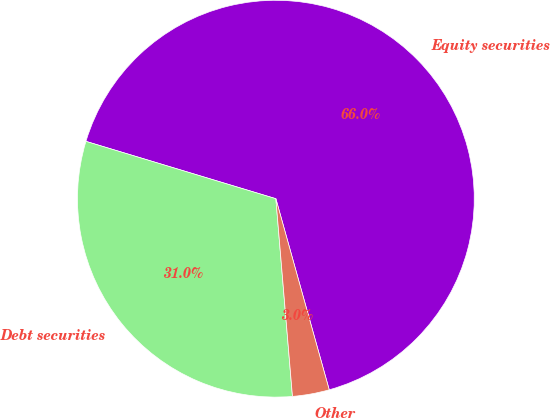<chart> <loc_0><loc_0><loc_500><loc_500><pie_chart><fcel>Equity securities<fcel>Debt securities<fcel>Other<nl><fcel>66.0%<fcel>31.0%<fcel>3.0%<nl></chart> 